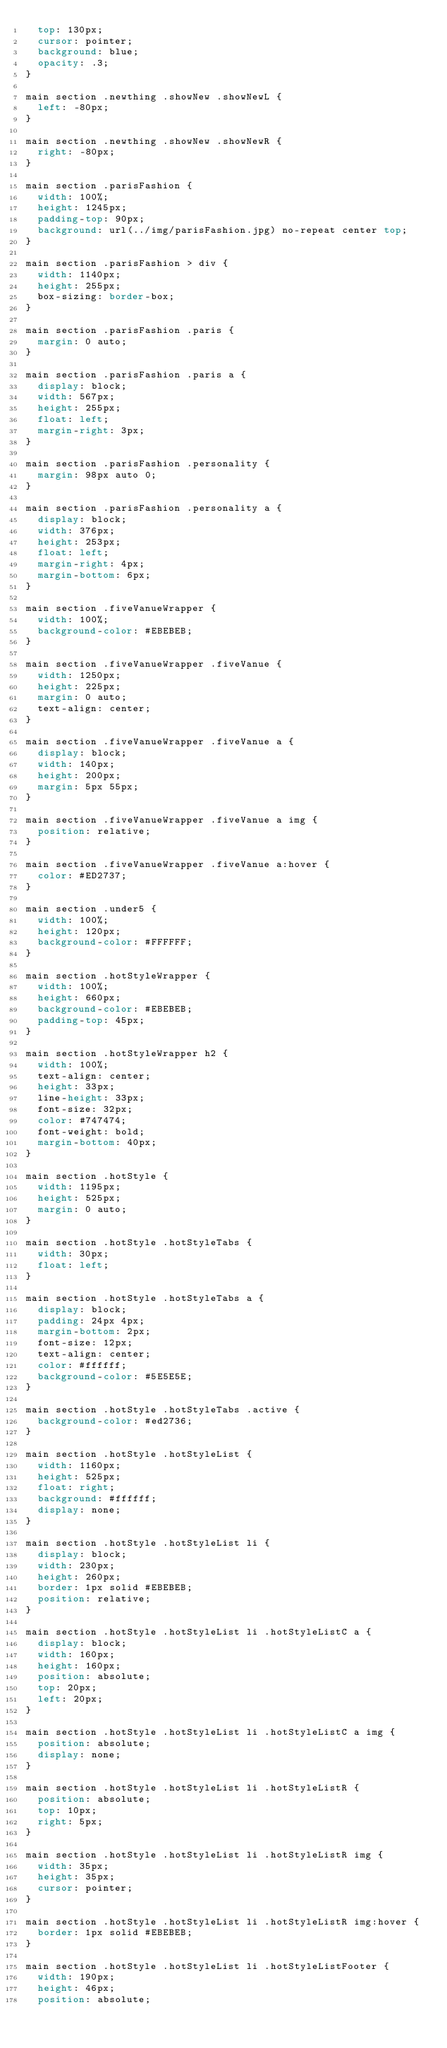<code> <loc_0><loc_0><loc_500><loc_500><_CSS_>  top: 130px;
  cursor: pointer;
  background: blue;
  opacity: .3;
}

main section .newthing .showNew .showNewL {
  left: -80px;
}

main section .newthing .showNew .showNewR {
  right: -80px;
}

main section .parisFashion {
  width: 100%;
  height: 1245px;
  padding-top: 90px;
  background: url(../img/parisFashion.jpg) no-repeat center top;
}

main section .parisFashion > div {
  width: 1140px;
  height: 255px;
  box-sizing: border-box;
}

main section .parisFashion .paris {
  margin: 0 auto;
}

main section .parisFashion .paris a {
  display: block;
  width: 567px;
  height: 255px;
  float: left;
  margin-right: 3px;
}

main section .parisFashion .personality {
  margin: 98px auto 0;
}

main section .parisFashion .personality a {
  display: block;
  width: 376px;
  height: 253px;
  float: left;
  margin-right: 4px;
  margin-bottom: 6px;
}

main section .fiveVanueWrapper {
  width: 100%;
  background-color: #EBEBEB;
}

main section .fiveVanueWrapper .fiveVanue {
  width: 1250px;
  height: 225px;
  margin: 0 auto;
  text-align: center;
}

main section .fiveVanueWrapper .fiveVanue a {
  display: block;
  width: 140px;
  height: 200px;
  margin: 5px 55px;
}

main section .fiveVanueWrapper .fiveVanue a img {
  position: relative;
}

main section .fiveVanueWrapper .fiveVanue a:hover {
  color: #ED2737;
}

main section .under5 {
  width: 100%;
  height: 120px;
  background-color: #FFFFFF;
}

main section .hotStyleWrapper {
  width: 100%;
  height: 660px;
  background-color: #EBEBEB;
  padding-top: 45px;
}

main section .hotStyleWrapper h2 {
  width: 100%;
  text-align: center;
  height: 33px;
  line-height: 33px;
  font-size: 32px;
  color: #747474;
  font-weight: bold;
  margin-bottom: 40px;
}

main section .hotStyle {
  width: 1195px;
  height: 525px;
  margin: 0 auto;
}

main section .hotStyle .hotStyleTabs {
  width: 30px;
  float: left;
}

main section .hotStyle .hotStyleTabs a {
  display: block;
  padding: 24px 4px;
  margin-bottom: 2px;
  font-size: 12px;
  text-align: center;
  color: #ffffff;
  background-color: #5E5E5E;
}

main section .hotStyle .hotStyleTabs .active {
  background-color: #ed2736;
}

main section .hotStyle .hotStyleList {
  width: 1160px;
  height: 525px;
  float: right;
  background: #ffffff;
  display: none;
}

main section .hotStyle .hotStyleList li {
  display: block;
  width: 230px;
  height: 260px;
  border: 1px solid #EBEBEB;
  position: relative;
}

main section .hotStyle .hotStyleList li .hotStyleListC a {
  display: block;
  width: 160px;
  height: 160px;
  position: absolute;
  top: 20px;
  left: 20px;
}

main section .hotStyle .hotStyleList li .hotStyleListC a img {
  position: absolute;
  display: none;
}

main section .hotStyle .hotStyleList li .hotStyleListR {
  position: absolute;
  top: 10px;
  right: 5px;
}

main section .hotStyle .hotStyleList li .hotStyleListR img {
  width: 35px;
  height: 35px;
  cursor: pointer;
}

main section .hotStyle .hotStyleList li .hotStyleListR img:hover {
  border: 1px solid #EBEBEB;
}

main section .hotStyle .hotStyleList li .hotStyleListFooter {
  width: 190px;
  height: 46px;
  position: absolute;</code> 